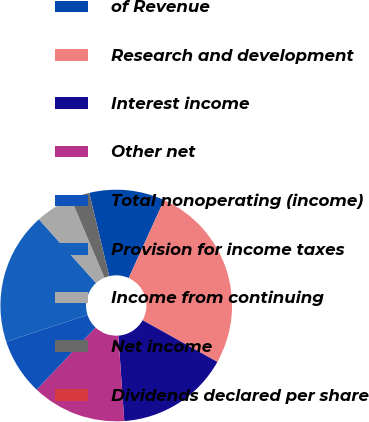<chart> <loc_0><loc_0><loc_500><loc_500><pie_chart><fcel>of Revenue<fcel>Research and development<fcel>Interest income<fcel>Other net<fcel>Total nonoperating (income)<fcel>Provision for income taxes<fcel>Income from continuing<fcel>Net income<fcel>Dividends declared per share<nl><fcel>10.53%<fcel>26.32%<fcel>15.79%<fcel>13.16%<fcel>7.89%<fcel>18.42%<fcel>5.26%<fcel>2.63%<fcel>0.0%<nl></chart> 